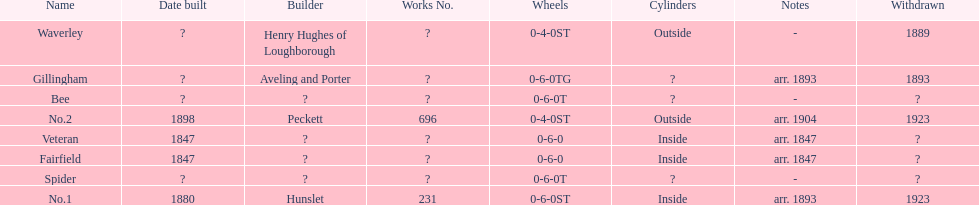Would you mind parsing the complete table? {'header': ['Name', 'Date built', 'Builder', 'Works No.', 'Wheels', 'Cylinders', 'Notes', 'Withdrawn'], 'rows': [['Waverley', '?', 'Henry Hughes of Loughborough', '?', '0-4-0ST', 'Outside', '-', '1889'], ['Gillingham', '?', 'Aveling and Porter', '?', '0-6-0TG', '?', 'arr. 1893', '1893'], ['Bee', '?', '?', '?', '0-6-0T', '?', '-', '?'], ['No.2', '1898', 'Peckett', '696', '0-4-0ST', 'Outside', 'arr. 1904', '1923'], ['Veteran', '1847', '?', '?', '0-6-0', 'Inside', 'arr. 1847', '?'], ['Fairfield', '1847', '?', '?', '0-6-0', 'Inside', 'arr. 1847', '?'], ['Spider', '?', '?', '?', '0-6-0T', '?', '-', '?'], ['No.1', '1880', 'Hunslet', '231', '0-6-0ST', 'Inside', 'arr. 1893', '1923']]} Were there more with inside or outside cylinders? Inside. 